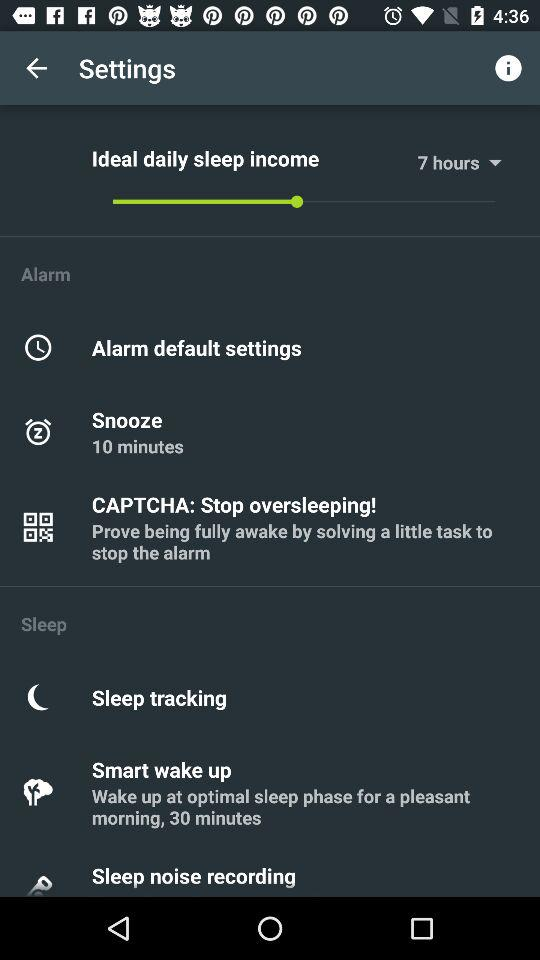What is the snooze time? The snooze time is 10 minutes. 